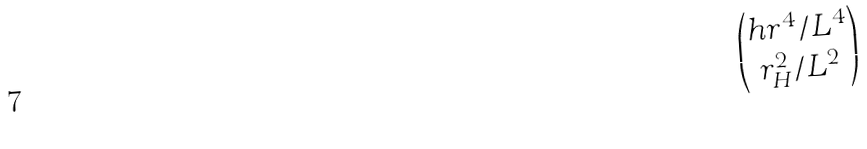Convert formula to latex. <formula><loc_0><loc_0><loc_500><loc_500>\begin{pmatrix} h r ^ { 4 } / L ^ { 4 } \\ r _ { H } ^ { 2 } / L ^ { 2 } \end{pmatrix}</formula> 